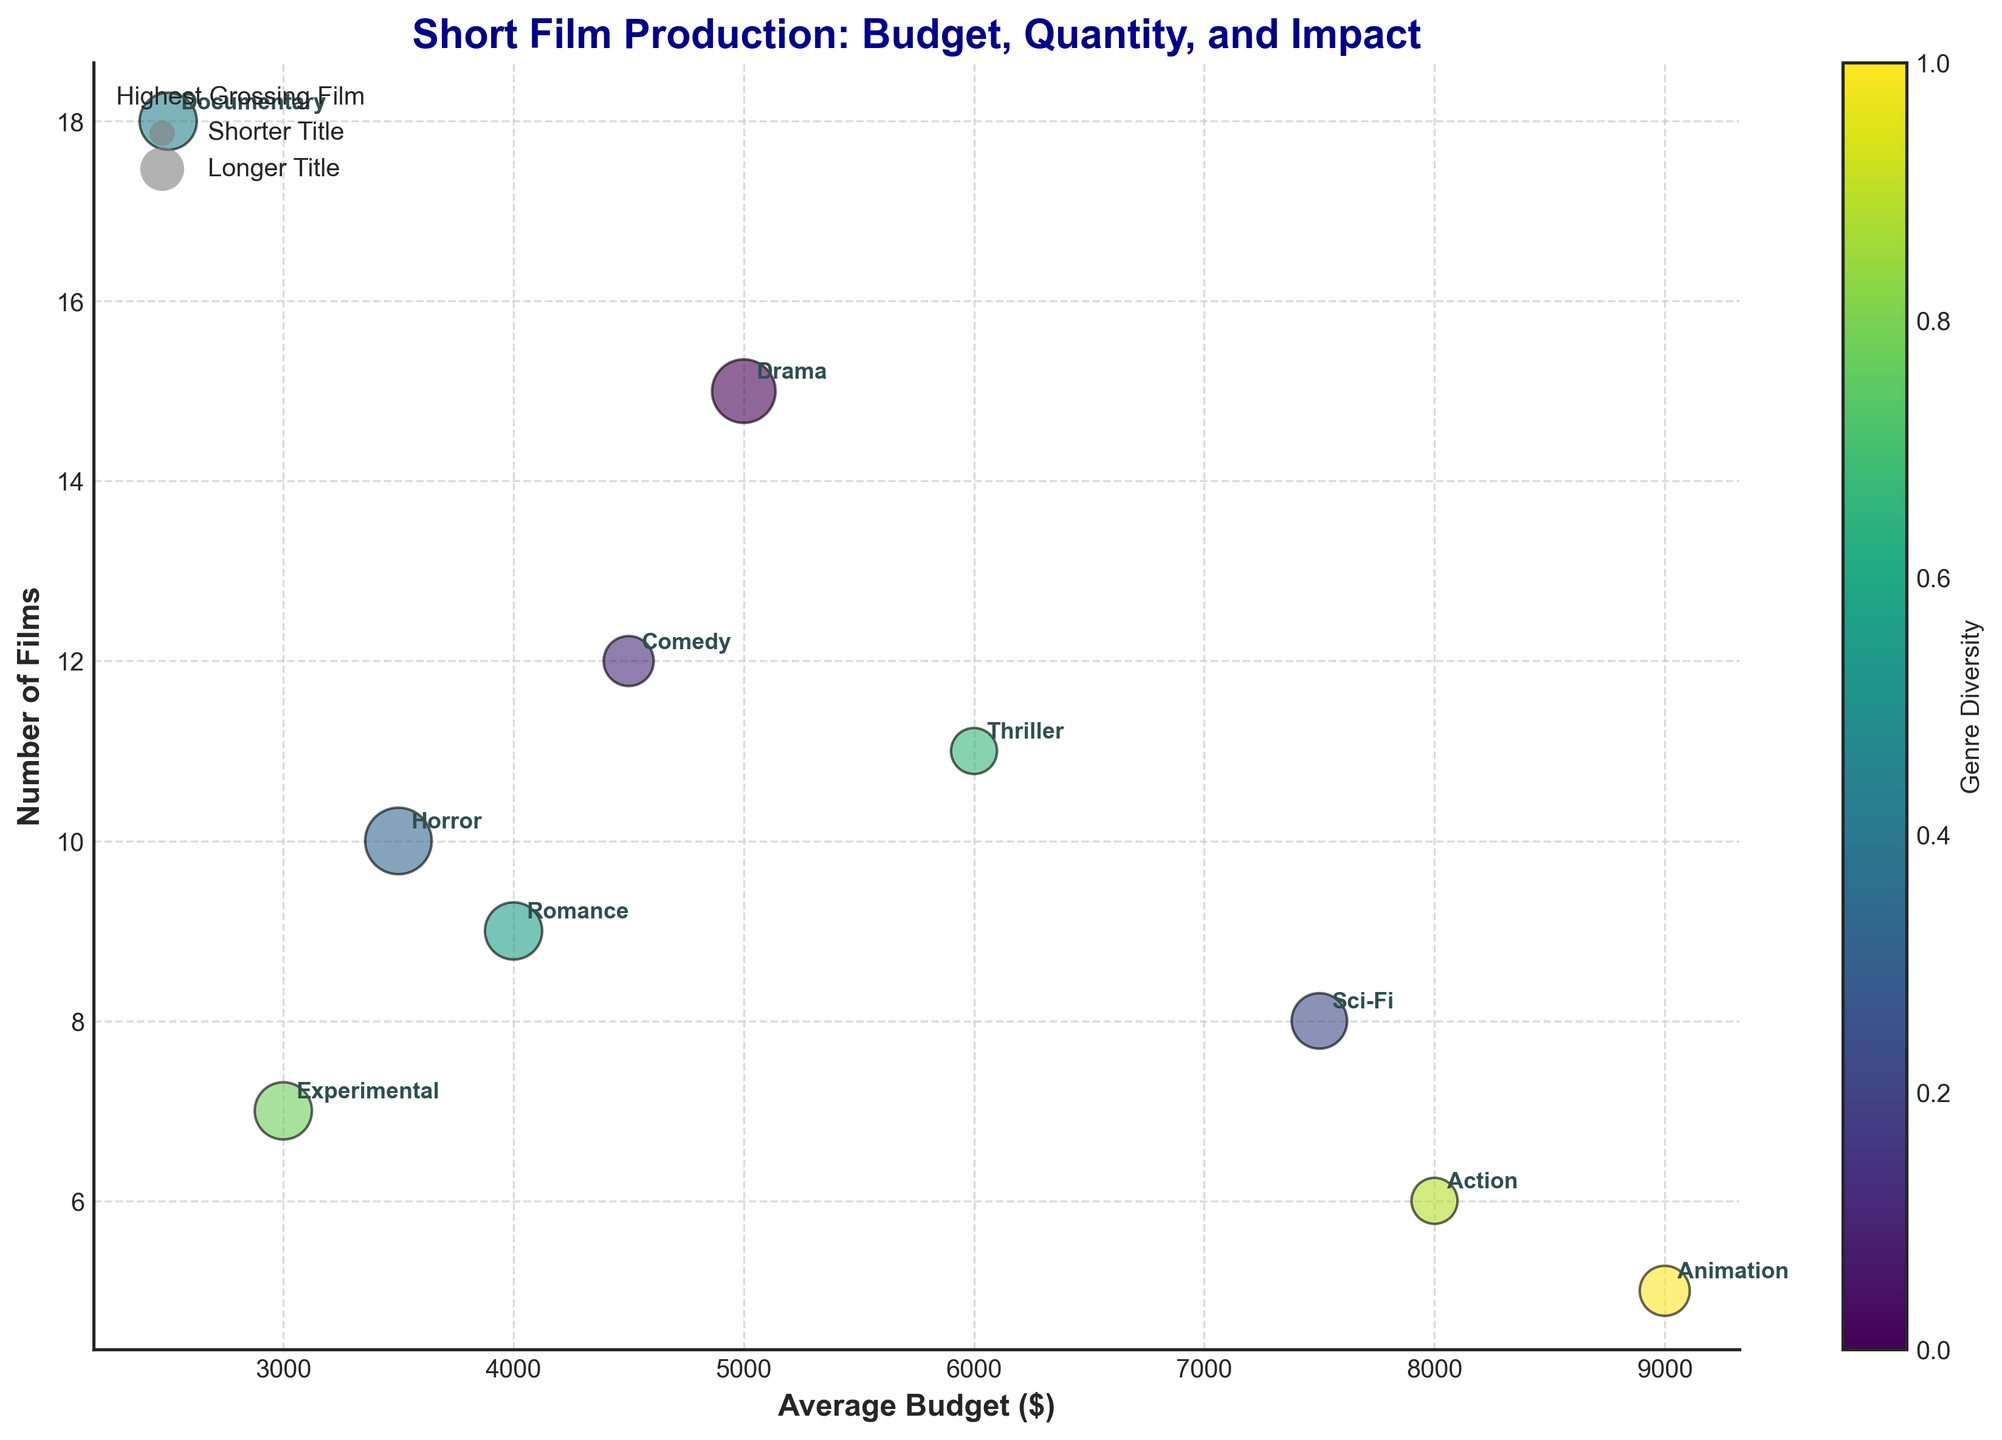What is the title of the figure? The title is written at the top of the figure.
Answer: Short Film Production: Budget, Quantity, and Impact Which genre has the highest average budget? The average budget values are represented on the x-axis, and Animation appears at the highest position.
Answer: Animation How many genres have an average budget of less than $5000? Count the number of genres with their average budget values to the left of the $5000 mark on the x-axis.
Answer: Six Which genre produced the highest number of films? The number of films is represented on the y-axis; the genre with the highest value for y is identified.
Answer: Documentary Which genre's highest-grossing film has the longest title? The size of the bubbles represents the length of the titles; compare the sizes to find the longest.
Answer: Beyond the Stars How many films does the Romance genre have? Locate the Romance genre and check its corresponding y-axis value.
Answer: Nine Is there any genre with both a higher average budget and a higher number of films than Thriller? Compare both the x and y values of Thriller with the other genres to find if any genre meets both criteria.
Answer: No Which genre has the smallest bubble size and how many films were produced in that genre? Identify the smallest bubble and find its corresponding genre and y-axis value.
Answer: Experimental, seven What is the combined number of films for Drama and Horror genres? Sum the y-axis values for both Drama and Horror.
Answer: Twenty-five How does the number of Action films compare to Sci-Fi films? Compare the y-axis values for Action and Sci-Fi and see which is larger.
Answer: Fewer 